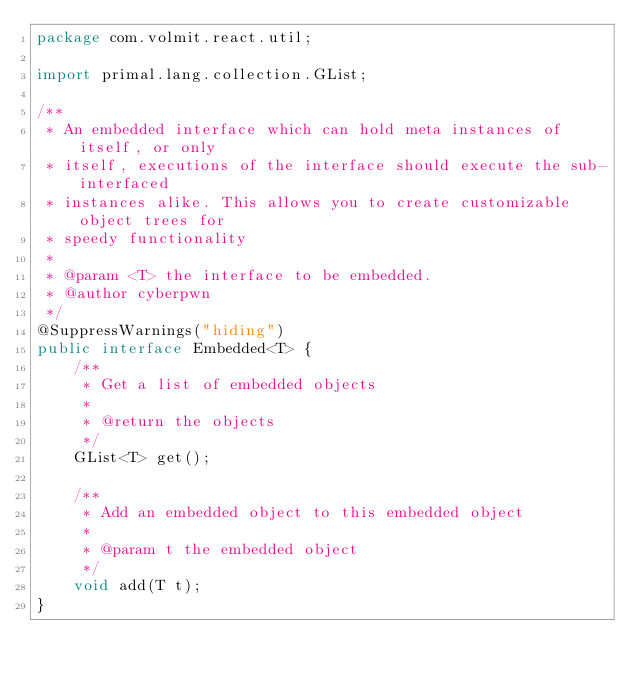Convert code to text. <code><loc_0><loc_0><loc_500><loc_500><_Java_>package com.volmit.react.util;

import primal.lang.collection.GList;

/**
 * An embedded interface which can hold meta instances of itself, or only
 * itself, executions of the interface should execute the sub-interfaced
 * instances alike. This allows you to create customizable object trees for
 * speedy functionality
 *
 * @param <T> the interface to be embedded.
 * @author cyberpwn
 */
@SuppressWarnings("hiding")
public interface Embedded<T> {
    /**
     * Get a list of embedded objects
     *
     * @return the objects
     */
    GList<T> get();

    /**
     * Add an embedded object to this embedded object
     *
     * @param t the embedded object
     */
    void add(T t);
}
</code> 